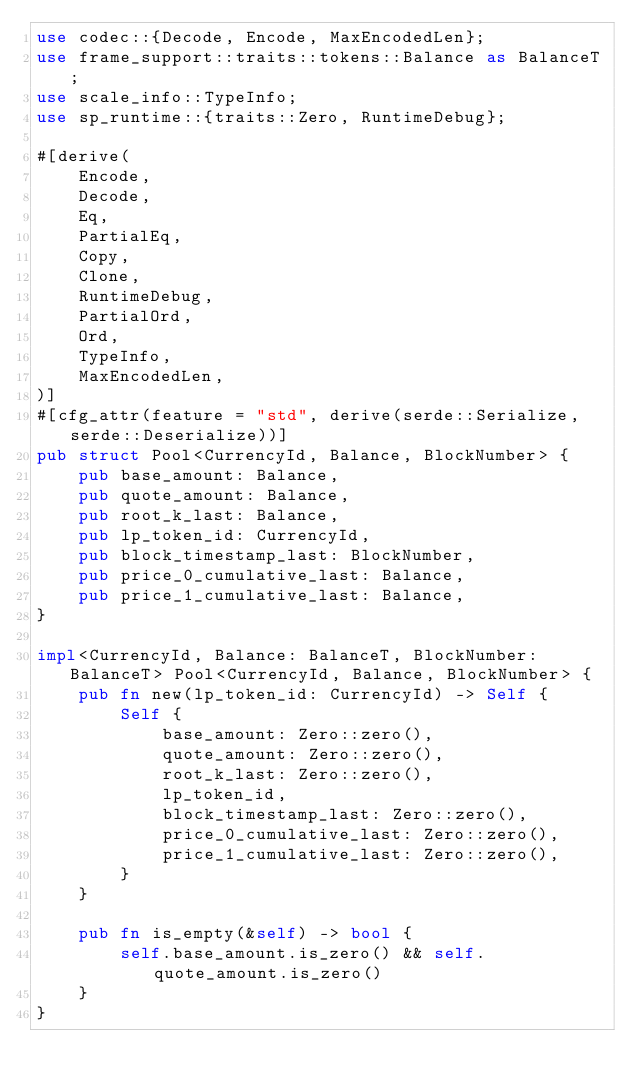<code> <loc_0><loc_0><loc_500><loc_500><_Rust_>use codec::{Decode, Encode, MaxEncodedLen};
use frame_support::traits::tokens::Balance as BalanceT;
use scale_info::TypeInfo;
use sp_runtime::{traits::Zero, RuntimeDebug};

#[derive(
    Encode,
    Decode,
    Eq,
    PartialEq,
    Copy,
    Clone,
    RuntimeDebug,
    PartialOrd,
    Ord,
    TypeInfo,
    MaxEncodedLen,
)]
#[cfg_attr(feature = "std", derive(serde::Serialize, serde::Deserialize))]
pub struct Pool<CurrencyId, Balance, BlockNumber> {
    pub base_amount: Balance,
    pub quote_amount: Balance,
    pub root_k_last: Balance,
    pub lp_token_id: CurrencyId,
    pub block_timestamp_last: BlockNumber,
    pub price_0_cumulative_last: Balance,
    pub price_1_cumulative_last: Balance,
}

impl<CurrencyId, Balance: BalanceT, BlockNumber: BalanceT> Pool<CurrencyId, Balance, BlockNumber> {
    pub fn new(lp_token_id: CurrencyId) -> Self {
        Self {
            base_amount: Zero::zero(),
            quote_amount: Zero::zero(),
            root_k_last: Zero::zero(),
            lp_token_id,
            block_timestamp_last: Zero::zero(),
            price_0_cumulative_last: Zero::zero(),
            price_1_cumulative_last: Zero::zero(),
        }
    }

    pub fn is_empty(&self) -> bool {
        self.base_amount.is_zero() && self.quote_amount.is_zero()
    }
}
</code> 